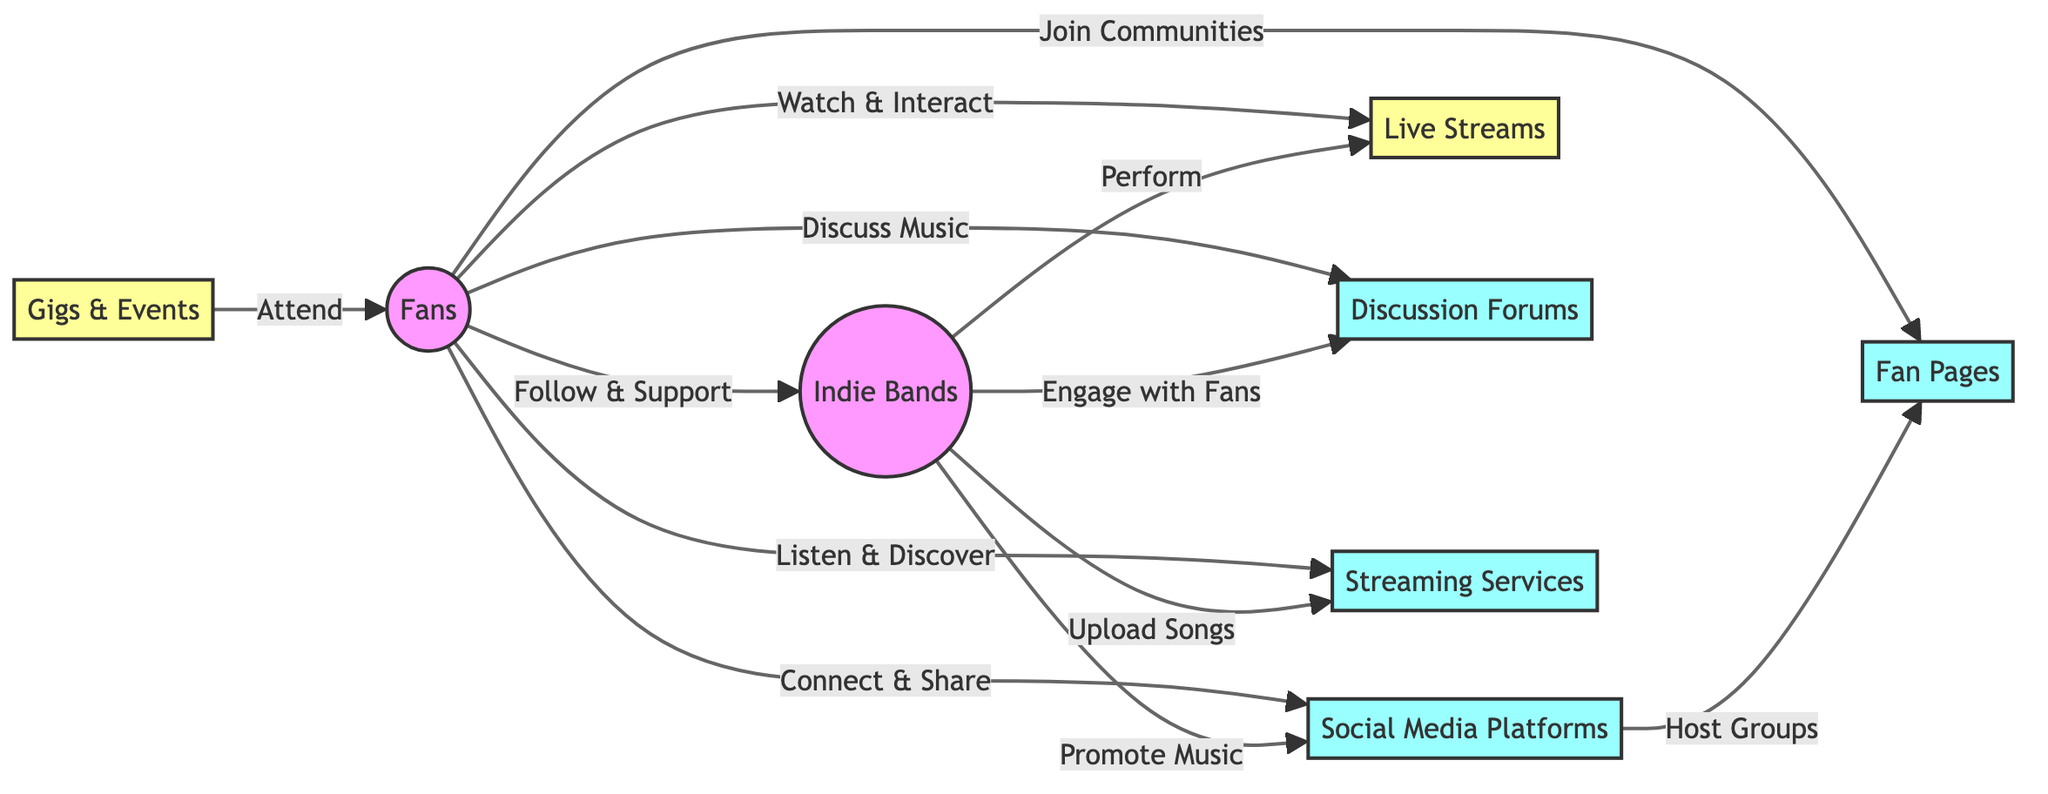What is the main activity that fans do with indie bands? The diagram shows an arrow leading from "Fans" to "Indie Bands" labeled "Follow & Support." This indicates that the primary activity is following and supporting the bands.
Answer: Follow & Support How do fans interact with social media platforms? The diagram depicts a connection from "Fans" to "Social Media Platforms" labelled "Connect & Share." This illustrates that fans utilize these platforms to connect and share content.
Answer: Connect & Share What type of platforms do fans join to build communities? There is a direct connection shown in the diagram from "Fans" to "Fan Pages" marked as "Join Communities." This indicates that fans join fan pages on social media to build communities.
Answer: Fan Pages How do indie bands engage with fans according to the diagram? The connections from "Indie Bands" to "Discussion Forums" indicate the bands "Engage with Fans." Therefore, this is how they interact.
Answer: Engage with Fans What type of events do indie bands perform at? The diagram shows "Indie Bands" linking to "Live Streams" with the label "Perform." This signifies the type of events where indie bands perform.
Answer: Live Streams How many platforms are listed in the diagram? The diagram features six distinct platforms: "Social Media Platforms," "Fan Pages," "Discussion Forums," "Streaming Services," "Live Streams," and "Gigs." Counting these gives a total of six.
Answer: 6 What activity do fans do in discussion forums? The diagram connects "Fans" to "Discussion Forums" with the phrase "Discuss Music," which indicates the activity fans engage in.
Answer: Discuss Music Which platforms do fans use to listen to and discover music? The diagram clearly shows an arrow from "Fans" to "Streaming Services" and is labeled "Listen & Discover," indicating these are the platforms used for this purpose.
Answer: Streaming Services How do indie bands upload their songs according to the diagram? The connection is made from "Indie Bands" to "Streaming Services" with "Upload Songs" as the label, signifying this is their method of uploading music.
Answer: Upload Songs 